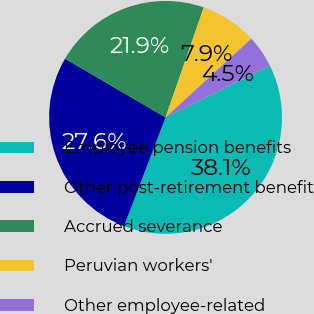Convert chart to OTSL. <chart><loc_0><loc_0><loc_500><loc_500><pie_chart><fcel>Employee pension benefits<fcel>Other post-retirement benefit<fcel>Accrued severance<fcel>Peruvian workers'<fcel>Other employee-related<nl><fcel>38.12%<fcel>27.61%<fcel>21.91%<fcel>7.86%<fcel>4.5%<nl></chart> 